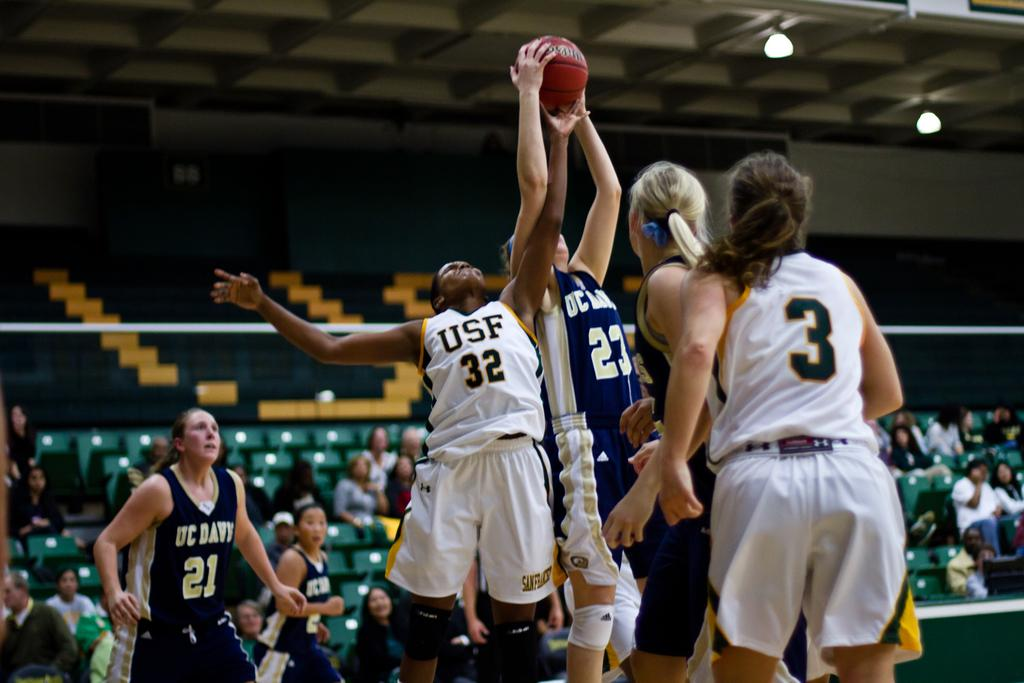<image>
Offer a succinct explanation of the picture presented. Basketball players vying for the ball The player from USF, number 32 almost has it. 